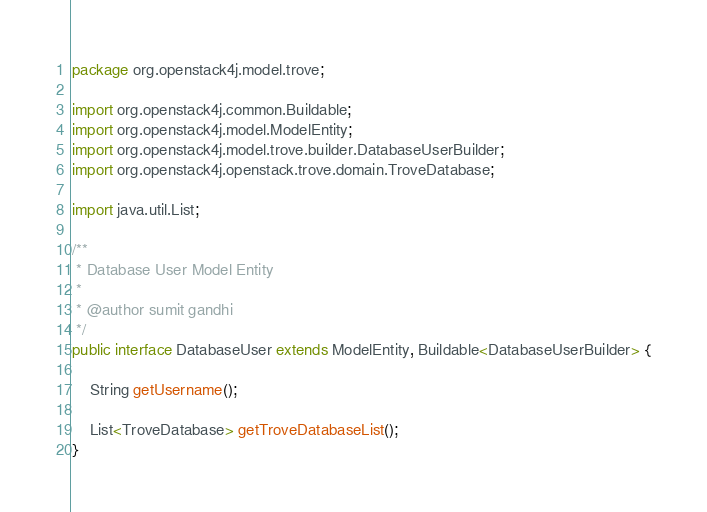Convert code to text. <code><loc_0><loc_0><loc_500><loc_500><_Java_>package org.openstack4j.model.trove;

import org.openstack4j.common.Buildable;
import org.openstack4j.model.ModelEntity;
import org.openstack4j.model.trove.builder.DatabaseUserBuilder;
import org.openstack4j.openstack.trove.domain.TroveDatabase;

import java.util.List;

/**
 * Database User Model Entity
 *
 * @author sumit gandhi
 */
public interface DatabaseUser extends ModelEntity, Buildable<DatabaseUserBuilder> {

    String getUsername();

    List<TroveDatabase> getTroveDatabaseList();
}
</code> 